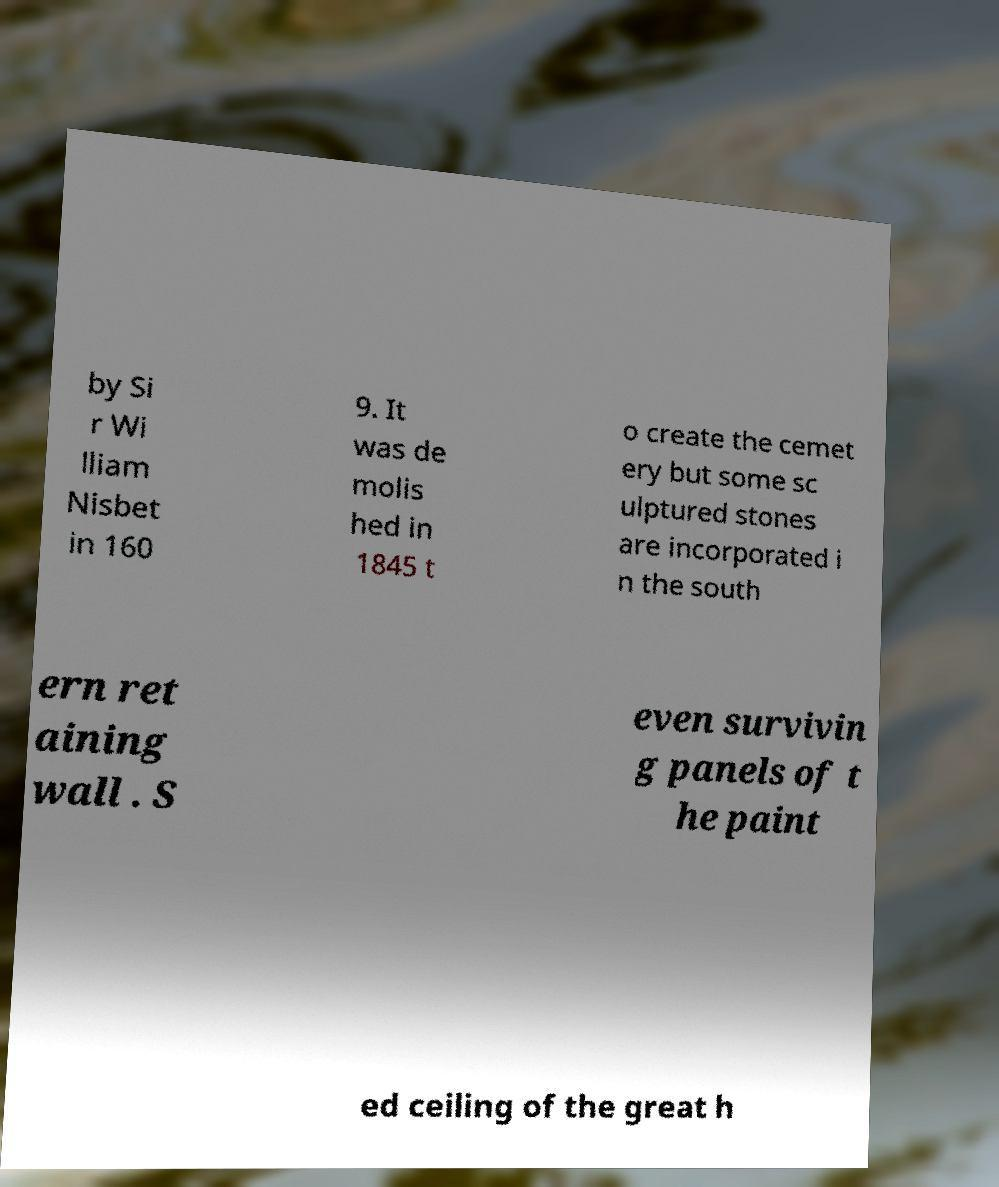Could you extract and type out the text from this image? by Si r Wi lliam Nisbet in 160 9. It was de molis hed in 1845 t o create the cemet ery but some sc ulptured stones are incorporated i n the south ern ret aining wall . S even survivin g panels of t he paint ed ceiling of the great h 